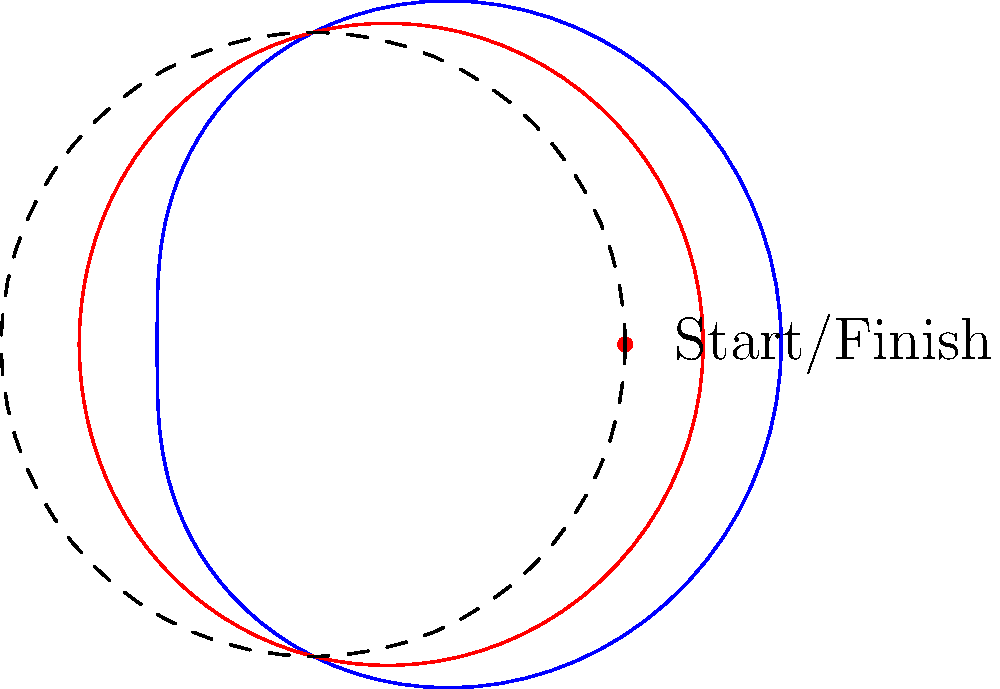As an aspiring rally driver, you're analyzing the optimal racing line through a curve using polar coordinates. The outer edge of the track is represented by $r = 2 + \cos(\theta)$, and the inner edge by $r = 2 + 0.5\cos(\theta)$. If you start at the point $(2,0)$ and want to maximize your exit speed, which of these polar equations best represents the ideal racing line through the curve?

A) $r = 2 + 0.75\cos(\theta)$
B) $r = 2 + 0.9\cos(\theta)$
C) $r = 2 + 0.6\cos(\theta)$
D) $r = 2 + 0.85\cos(\theta)$ To determine the optimal racing line, we need to consider the following steps:

1) The ideal racing line should start from the outside of the curve, cut to the inside at the apex, and then move back to the outside for the exit.

2) Given that we start at $(2,0)$, which is on the dashed circle $r=2$, we want a line that:
   - Begins close to the outer edge $(2 + \cos(\theta))$
   - Moves towards the inner edge $(2 + 0.5\cos(\theta))$ at the midpoint
   - Ends closer to the outer edge again

3) Looking at the options:
   A) $r = 2 + 0.75\cos(\theta)$ is halfway between the edges, not ideal
   B) $r = 2 + 0.9\cos(\theta)$ stays too close to the outer edge
   C) $r = 2 + 0.6\cos(\theta)$ is too close to the inner edge
   D) $r = 2 + 0.85\cos(\theta)$ starts near the outer edge, cuts in (but not too far), and allows for a wide exit

4) Option D provides the best balance, allowing for a wide entry, a good apex, and a wide exit to maximize speed.

This racing line would allow you to carry more speed through the corner and have a better exit speed, which is crucial in rally driving.
Answer: D) $r = 2 + 0.85\cos(\theta)$ 